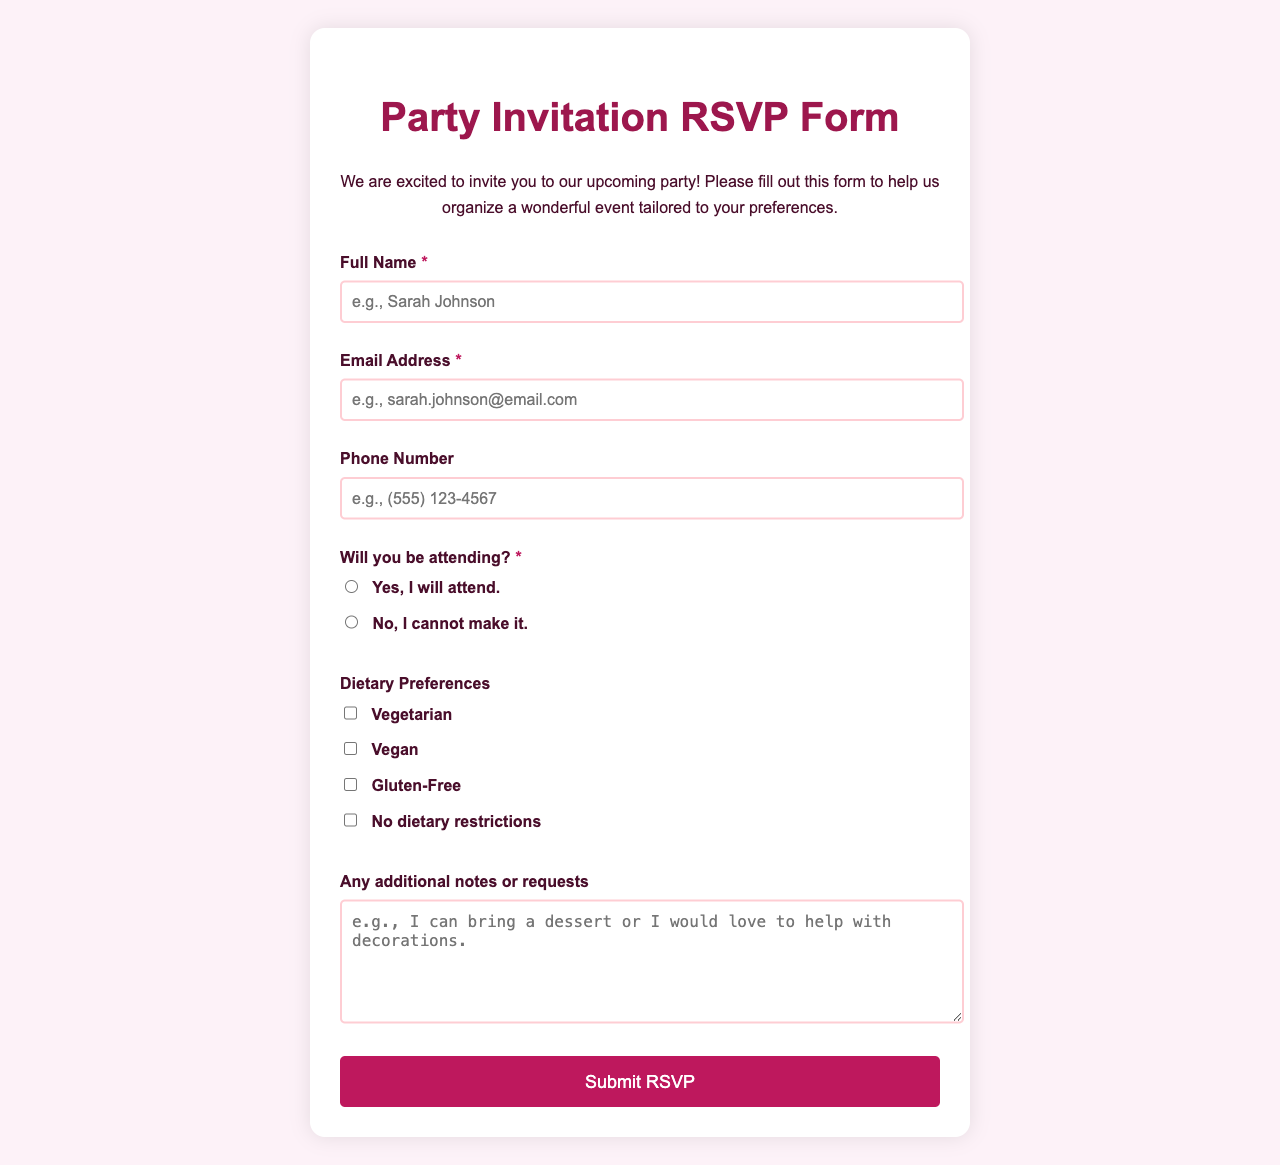What is the title of the document? The title is indicated in the <title> tag of the HTML document.
Answer: Party Invitation RSVP Form What is the main color scheme used in the document? The main color scheme can be determined by examining the background and text colors specified in the CSS.
Answer: Pink and dark purple What is the required field for the full name? The form specifies a required field for full name entries, which is explicitly mentioned in the label.
Answer: Full Name How many dietary preferences options are available? The number of options can be counted from the checkboxes provided in the dietary preferences section.
Answer: Four What is the placeholder text for the email input? The placeholder text for the email input offers an example format for user input.
Answer: e.g., sarah.johnson@email.com What color is the submit button when hovered over? The hover color is specified in the button's CSS style which changes when the cursor is over it.
Answer: Dark purple Is there any field for additional notes? The presence of a field for extra notes is indicated in the form structure.
Answer: Yes What is the font used in the document? The font is specified in the CSS and can be identified from the body style.
Answer: Quicksand For attendance, how many options are provided? The attendance section offers different responses that can be counted.
Answer: Two 